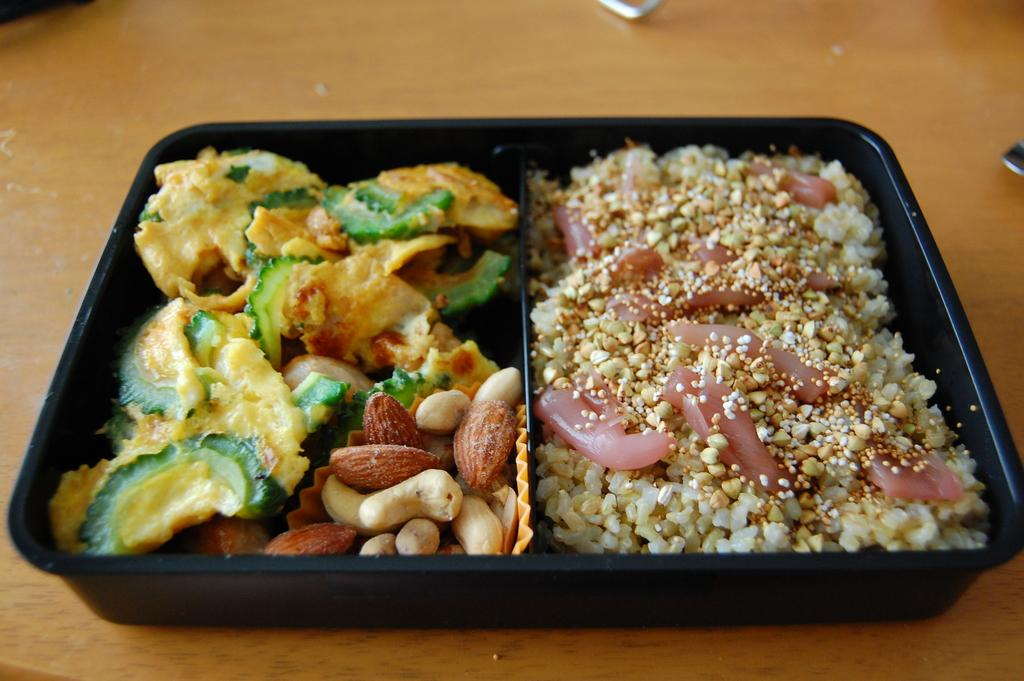What piece of furniture is present in the image? There is a table in the image. What is placed on the table? There is a box on the table. What can be found inside the box? There are food items in the box. What type of worm can be seen crawling on the table in the image? There is no worm present in the image; the image only features a table, a box, and food items. 